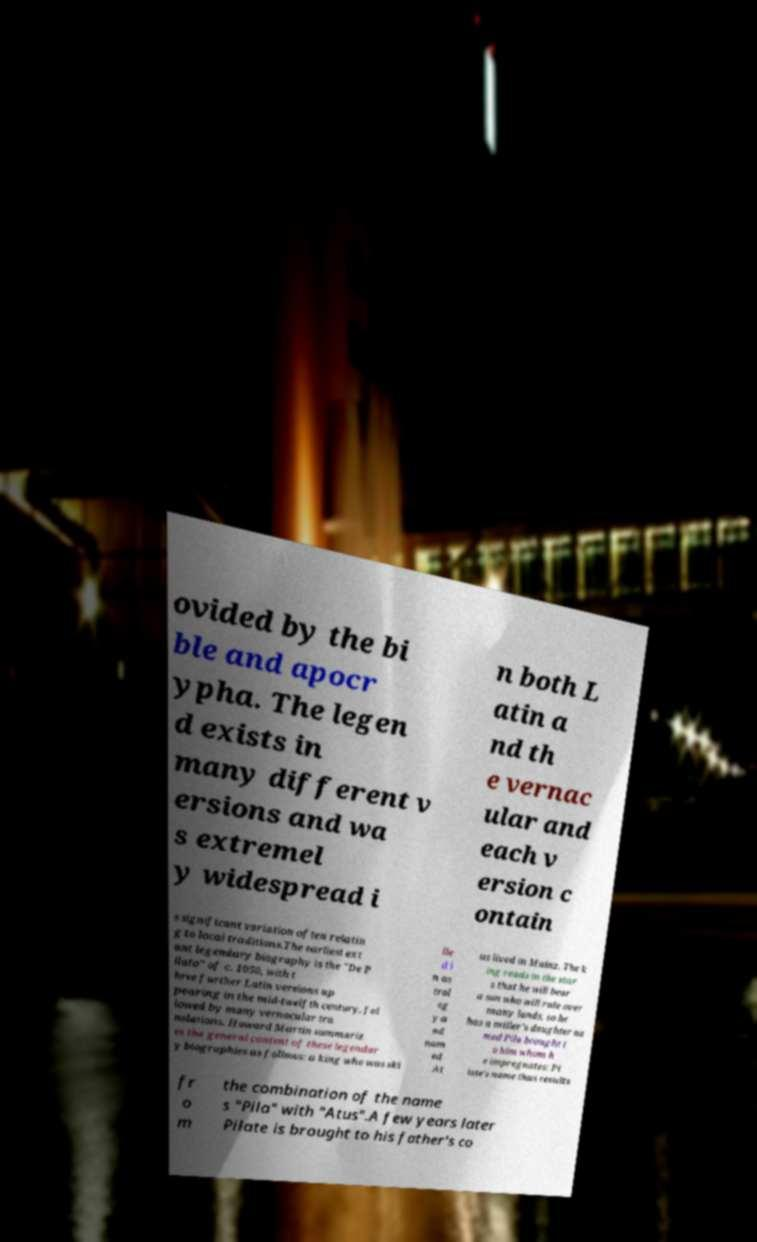I need the written content from this picture converted into text. Can you do that? ovided by the bi ble and apocr ypha. The legen d exists in many different v ersions and wa s extremel y widespread i n both L atin a nd th e vernac ular and each v ersion c ontain s significant variation often relatin g to local traditions.The earliest ext ant legendary biography is the "De P ilato" of c. 1050, with t hree further Latin versions ap pearing in the mid-twelfth century, fol lowed by many vernacular tra nslations. Howard Martin summariz es the general content of these legendar y biographies as follows: a king who was ski lle d i n as trol og y a nd nam ed At us lived in Mainz. The k ing reads in the star s that he will bear a son who will rule over many lands, so he has a miller's daughter na med Pila brought t o him whom h e impregnates; Pi late's name thus results fr o m the combination of the name s "Pila" with "Atus".A few years later Pilate is brought to his father's co 